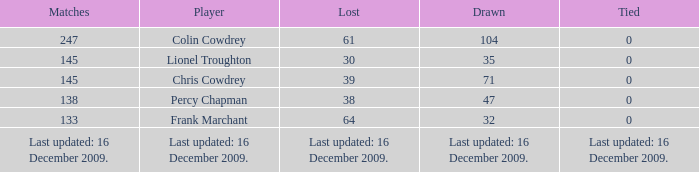Name the tie that has 71 drawn 0.0. 